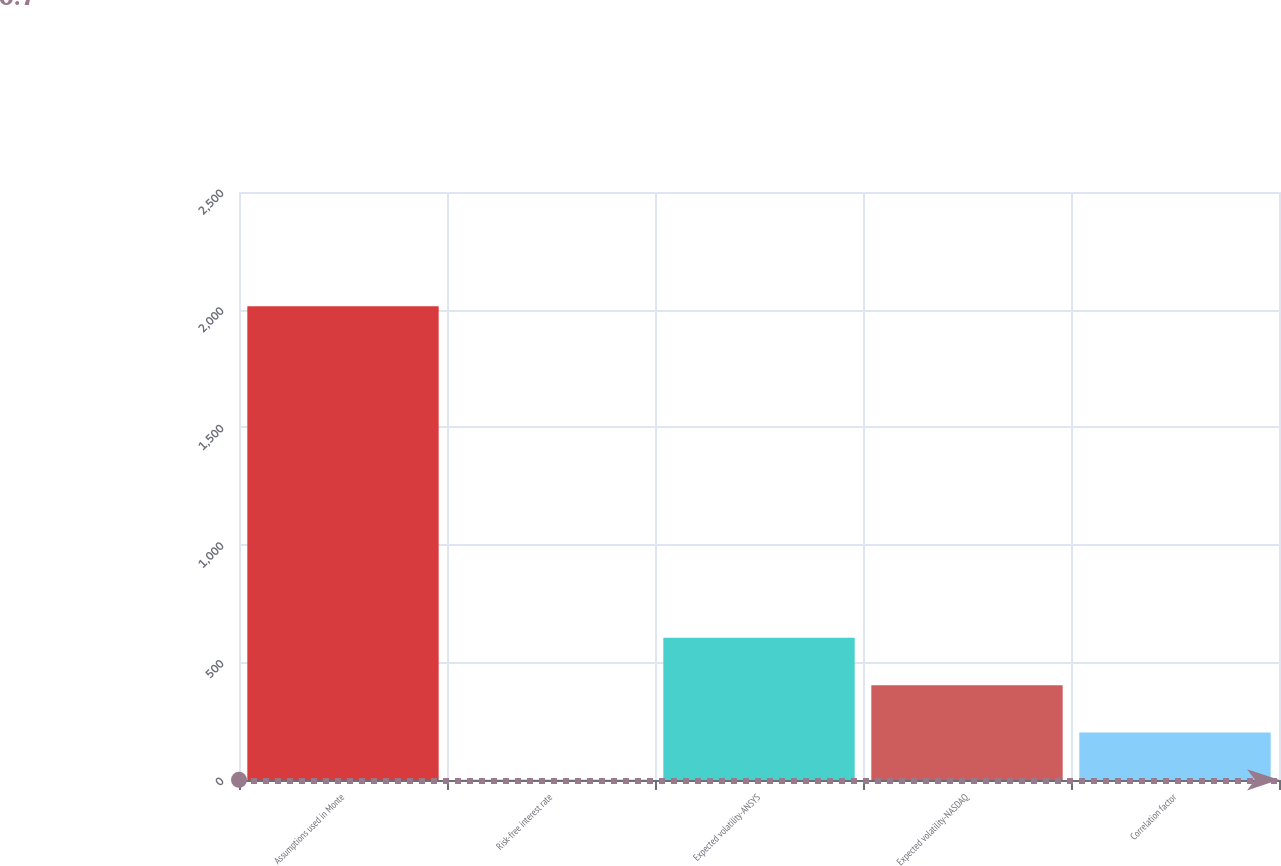Convert chart to OTSL. <chart><loc_0><loc_0><loc_500><loc_500><bar_chart><fcel>Assumptions used in Monte<fcel>Risk-free interest rate<fcel>Expected volatility-ANSYS<fcel>Expected volatility-NASDAQ<fcel>Correlation factor<nl><fcel>2014<fcel>0.7<fcel>604.69<fcel>403.36<fcel>202.03<nl></chart> 